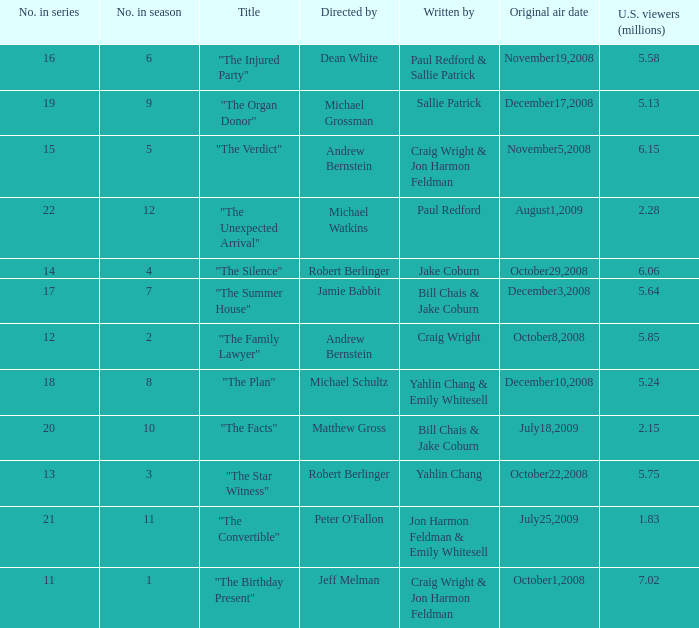Could you parse the entire table as a dict? {'header': ['No. in series', 'No. in season', 'Title', 'Directed by', 'Written by', 'Original air date', 'U.S. viewers (millions)'], 'rows': [['16', '6', '"The Injured Party"', 'Dean White', 'Paul Redford & Sallie Patrick', 'November19,2008', '5.58'], ['19', '9', '"The Organ Donor"', 'Michael Grossman', 'Sallie Patrick', 'December17,2008', '5.13'], ['15', '5', '"The Verdict"', 'Andrew Bernstein', 'Craig Wright & Jon Harmon Feldman', 'November5,2008', '6.15'], ['22', '12', '"The Unexpected Arrival"', 'Michael Watkins', 'Paul Redford', 'August1,2009', '2.28'], ['14', '4', '"The Silence"', 'Robert Berlinger', 'Jake Coburn', 'October29,2008', '6.06'], ['17', '7', '"The Summer House"', 'Jamie Babbit', 'Bill Chais & Jake Coburn', 'December3,2008', '5.64'], ['12', '2', '"The Family Lawyer"', 'Andrew Bernstein', 'Craig Wright', 'October8,2008', '5.85'], ['18', '8', '"The Plan"', 'Michael Schultz', 'Yahlin Chang & Emily Whitesell', 'December10,2008', '5.24'], ['20', '10', '"The Facts"', 'Matthew Gross', 'Bill Chais & Jake Coburn', 'July18,2009', '2.15'], ['13', '3', '"The Star Witness"', 'Robert Berlinger', 'Yahlin Chang', 'October22,2008', '5.75'], ['21', '11', '"The Convertible"', "Peter O'Fallon", 'Jon Harmon Feldman & Emily Whitesell', 'July25,2009', '1.83'], ['11', '1', '"The Birthday Present"', 'Jeff Melman', 'Craig Wright & Jon Harmon Feldman', 'October1,2008', '7.02']]} What is the original air date of the episode directed by Jeff Melman? October1,2008. 